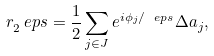<formula> <loc_0><loc_0><loc_500><loc_500>r _ { 2 } ^ { \ } e p s = \frac { 1 } { 2 } \sum _ { j \in J } e ^ { i \phi _ { j } / \ e p s } \Delta a _ { j } ,</formula> 